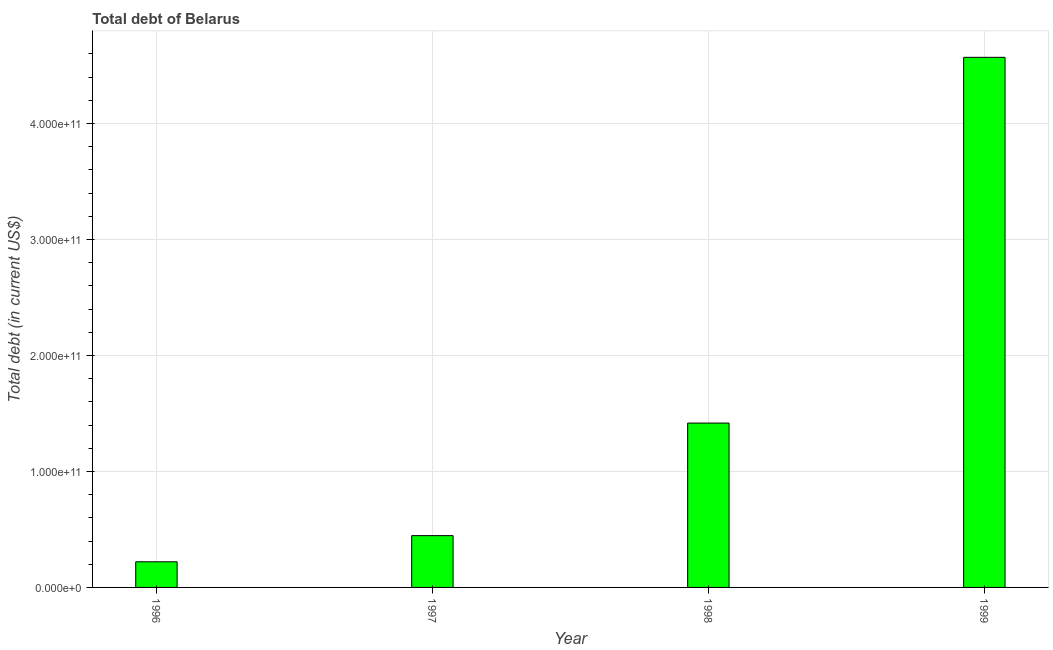What is the title of the graph?
Make the answer very short. Total debt of Belarus. What is the label or title of the X-axis?
Provide a short and direct response. Year. What is the label or title of the Y-axis?
Offer a terse response. Total debt (in current US$). What is the total debt in 1996?
Your response must be concise. 2.21e+1. Across all years, what is the maximum total debt?
Keep it short and to the point. 4.57e+11. Across all years, what is the minimum total debt?
Provide a short and direct response. 2.21e+1. In which year was the total debt maximum?
Give a very brief answer. 1999. What is the sum of the total debt?
Your response must be concise. 6.65e+11. What is the difference between the total debt in 1998 and 1999?
Your response must be concise. -3.15e+11. What is the average total debt per year?
Give a very brief answer. 1.66e+11. What is the median total debt?
Give a very brief answer. 9.32e+1. Do a majority of the years between 1999 and 1997 (inclusive) have total debt greater than 300000000000 US$?
Keep it short and to the point. Yes. What is the ratio of the total debt in 1998 to that in 1999?
Your response must be concise. 0.31. What is the difference between the highest and the second highest total debt?
Give a very brief answer. 3.15e+11. What is the difference between the highest and the lowest total debt?
Your answer should be very brief. 4.35e+11. How many bars are there?
Offer a very short reply. 4. Are all the bars in the graph horizontal?
Ensure brevity in your answer.  No. What is the difference between two consecutive major ticks on the Y-axis?
Keep it short and to the point. 1.00e+11. What is the Total debt (in current US$) of 1996?
Your answer should be compact. 2.21e+1. What is the Total debt (in current US$) of 1997?
Provide a short and direct response. 4.46e+1. What is the Total debt (in current US$) in 1998?
Provide a short and direct response. 1.42e+11. What is the Total debt (in current US$) of 1999?
Make the answer very short. 4.57e+11. What is the difference between the Total debt (in current US$) in 1996 and 1997?
Ensure brevity in your answer.  -2.25e+1. What is the difference between the Total debt (in current US$) in 1996 and 1998?
Give a very brief answer. -1.20e+11. What is the difference between the Total debt (in current US$) in 1996 and 1999?
Your answer should be compact. -4.35e+11. What is the difference between the Total debt (in current US$) in 1997 and 1998?
Provide a short and direct response. -9.71e+1. What is the difference between the Total debt (in current US$) in 1997 and 1999?
Give a very brief answer. -4.12e+11. What is the difference between the Total debt (in current US$) in 1998 and 1999?
Give a very brief answer. -3.15e+11. What is the ratio of the Total debt (in current US$) in 1996 to that in 1997?
Ensure brevity in your answer.  0.49. What is the ratio of the Total debt (in current US$) in 1996 to that in 1998?
Provide a succinct answer. 0.16. What is the ratio of the Total debt (in current US$) in 1996 to that in 1999?
Your response must be concise. 0.05. What is the ratio of the Total debt (in current US$) in 1997 to that in 1998?
Keep it short and to the point. 0.32. What is the ratio of the Total debt (in current US$) in 1997 to that in 1999?
Offer a very short reply. 0.1. What is the ratio of the Total debt (in current US$) in 1998 to that in 1999?
Offer a very short reply. 0.31. 